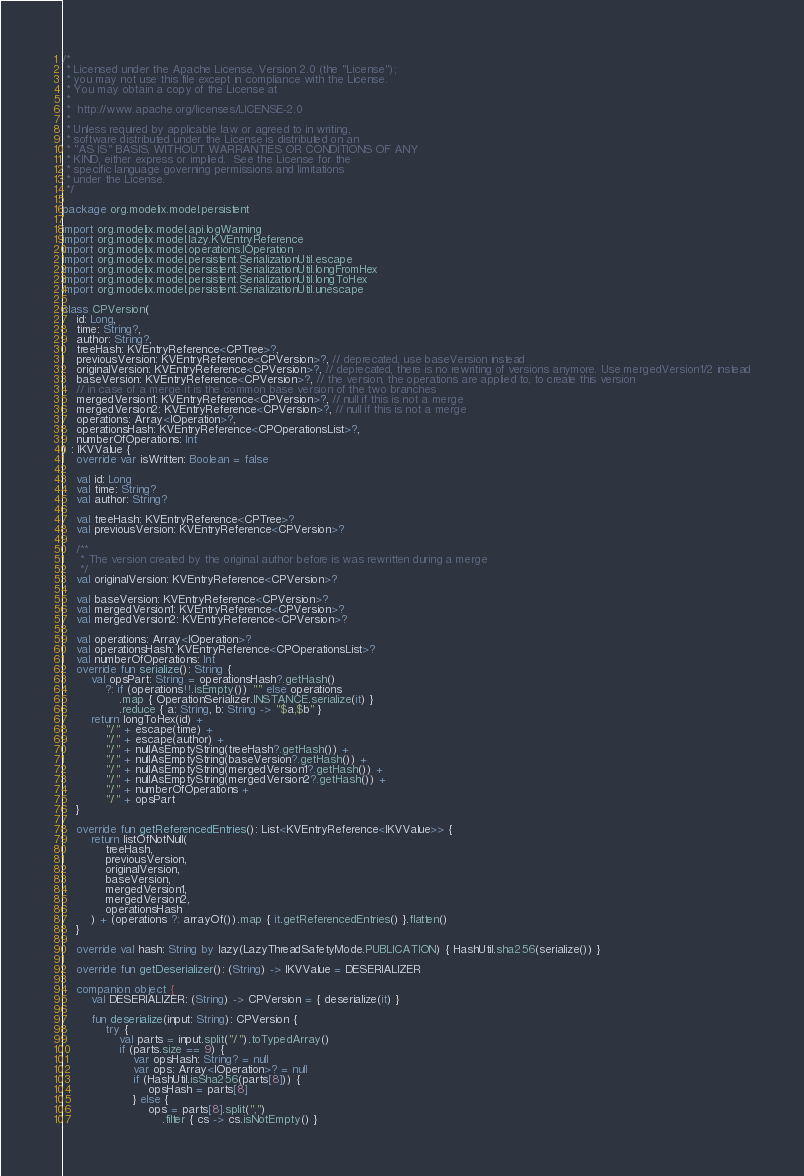<code> <loc_0><loc_0><loc_500><loc_500><_Kotlin_>/*
 * Licensed under the Apache License, Version 2.0 (the "License");
 * you may not use this file except in compliance with the License.
 * You may obtain a copy of the License at
 *
 *  http://www.apache.org/licenses/LICENSE-2.0
 *
 * Unless required by applicable law or agreed to in writing,
 * software distributed under the License is distributed on an
 * "AS IS" BASIS, WITHOUT WARRANTIES OR CONDITIONS OF ANY
 * KIND, either express or implied.  See the License for the
 * specific language governing permissions and limitations
 * under the License. 
 */

package org.modelix.model.persistent

import org.modelix.model.api.logWarning
import org.modelix.model.lazy.KVEntryReference
import org.modelix.model.operations.IOperation
import org.modelix.model.persistent.SerializationUtil.escape
import org.modelix.model.persistent.SerializationUtil.longFromHex
import org.modelix.model.persistent.SerializationUtil.longToHex
import org.modelix.model.persistent.SerializationUtil.unescape

class CPVersion(
    id: Long,
    time: String?,
    author: String?,
    treeHash: KVEntryReference<CPTree>?,
    previousVersion: KVEntryReference<CPVersion>?, // deprecated, use baseVersion instead
    originalVersion: KVEntryReference<CPVersion>?, // deprecated, there is no rewriting of versions anymore. Use mergedVersion1/2 instead
    baseVersion: KVEntryReference<CPVersion>?, // the version, the operations are applied to, to create this version
    // in case of a merge it is the common base version of the two branches
    mergedVersion1: KVEntryReference<CPVersion>?, // null if this is not a merge
    mergedVersion2: KVEntryReference<CPVersion>?, // null if this is not a merge
    operations: Array<IOperation>?,
    operationsHash: KVEntryReference<CPOperationsList>?,
    numberOfOperations: Int
) : IKVValue {
    override var isWritten: Boolean = false

    val id: Long
    val time: String?
    val author: String?

    val treeHash: KVEntryReference<CPTree>?
    val previousVersion: KVEntryReference<CPVersion>?

    /**
     * The version created by the original author before is was rewritten during a merge
     */
    val originalVersion: KVEntryReference<CPVersion>?

    val baseVersion: KVEntryReference<CPVersion>?
    val mergedVersion1: KVEntryReference<CPVersion>?
    val mergedVersion2: KVEntryReference<CPVersion>?

    val operations: Array<IOperation>?
    val operationsHash: KVEntryReference<CPOperationsList>?
    val numberOfOperations: Int
    override fun serialize(): String {
        val opsPart: String = operationsHash?.getHash()
            ?: if (operations!!.isEmpty()) "" else operations
                .map { OperationSerializer.INSTANCE.serialize(it) }
                .reduce { a: String, b: String -> "$a,$b" }
        return longToHex(id) +
            "/" + escape(time) +
            "/" + escape(author) +
            "/" + nullAsEmptyString(treeHash?.getHash()) +
            "/" + nullAsEmptyString(baseVersion?.getHash()) +
            "/" + nullAsEmptyString(mergedVersion1?.getHash()) +
            "/" + nullAsEmptyString(mergedVersion2?.getHash()) +
            "/" + numberOfOperations +
            "/" + opsPart
    }

    override fun getReferencedEntries(): List<KVEntryReference<IKVValue>> {
        return listOfNotNull(
            treeHash,
            previousVersion,
            originalVersion,
            baseVersion,
            mergedVersion1,
            mergedVersion2,
            operationsHash
        ) + (operations ?: arrayOf()).map { it.getReferencedEntries() }.flatten()
    }

    override val hash: String by lazy(LazyThreadSafetyMode.PUBLICATION) { HashUtil.sha256(serialize()) }

    override fun getDeserializer(): (String) -> IKVValue = DESERIALIZER

    companion object {
        val DESERIALIZER: (String) -> CPVersion = { deserialize(it) }

        fun deserialize(input: String): CPVersion {
            try {
                val parts = input.split("/").toTypedArray()
                if (parts.size == 9) {
                    var opsHash: String? = null
                    var ops: Array<IOperation>? = null
                    if (HashUtil.isSha256(parts[8])) {
                        opsHash = parts[8]
                    } else {
                        ops = parts[8].split(",")
                            .filter { cs -> cs.isNotEmpty() }</code> 